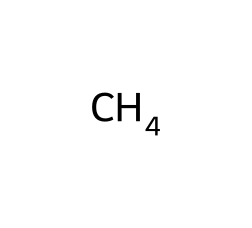What is the molecular formula of methane? The SMILES representation "C" indicates the presence of one carbon atom and assumes the complete saturation of hydrogen atoms which are associated with that carbon in methane. The full molecular formula for methane is thus one carbon and four hydrogens, written as CH4.
Answer: CH4 How many hydrogen atoms are in methane? From the molecular formula CH4, it is clear that there are four hydrogen atoms connected to the single carbon atom in methane.
Answer: 4 What type of bond connects the carbon and hydrogen atoms in methane? The carbon atom in methane forms single covalent bonds with each of the four hydrogen atoms. Each of these connections involves a shared pair of electrons, which characterizes a covalent bond.
Answer: single covalent bond What is the state of methane at room temperature? Given that methane is a gas at room temperature, this can be attributed to its low molecular weight and the nature of the intermolecular forces, which are weak van der Waals forces.
Answer: gas Why is methane considered a greenhouse gas? Methane is classified as a greenhouse gas because it has the ability to trap heat in the atmosphere, which is confirmed by its molecular structure that allows it to absorb infrared radiation effectively.
Answer: because it traps heat What is the primary use of methane? The main application of methane is as a fuel source, commonly utilized for heating, cooking, and electricity generation, largely due to its energy content as a combustible gas.
Answer: fuel source How does the structure of methane contribute to its properties? The tetrahedral structure of methane, with four hydrogen atoms symmetrically arranged around a central carbon atom, leads to high stability and results in its gaseous state and effective combustion properties.
Answer: tetrahedral structure 